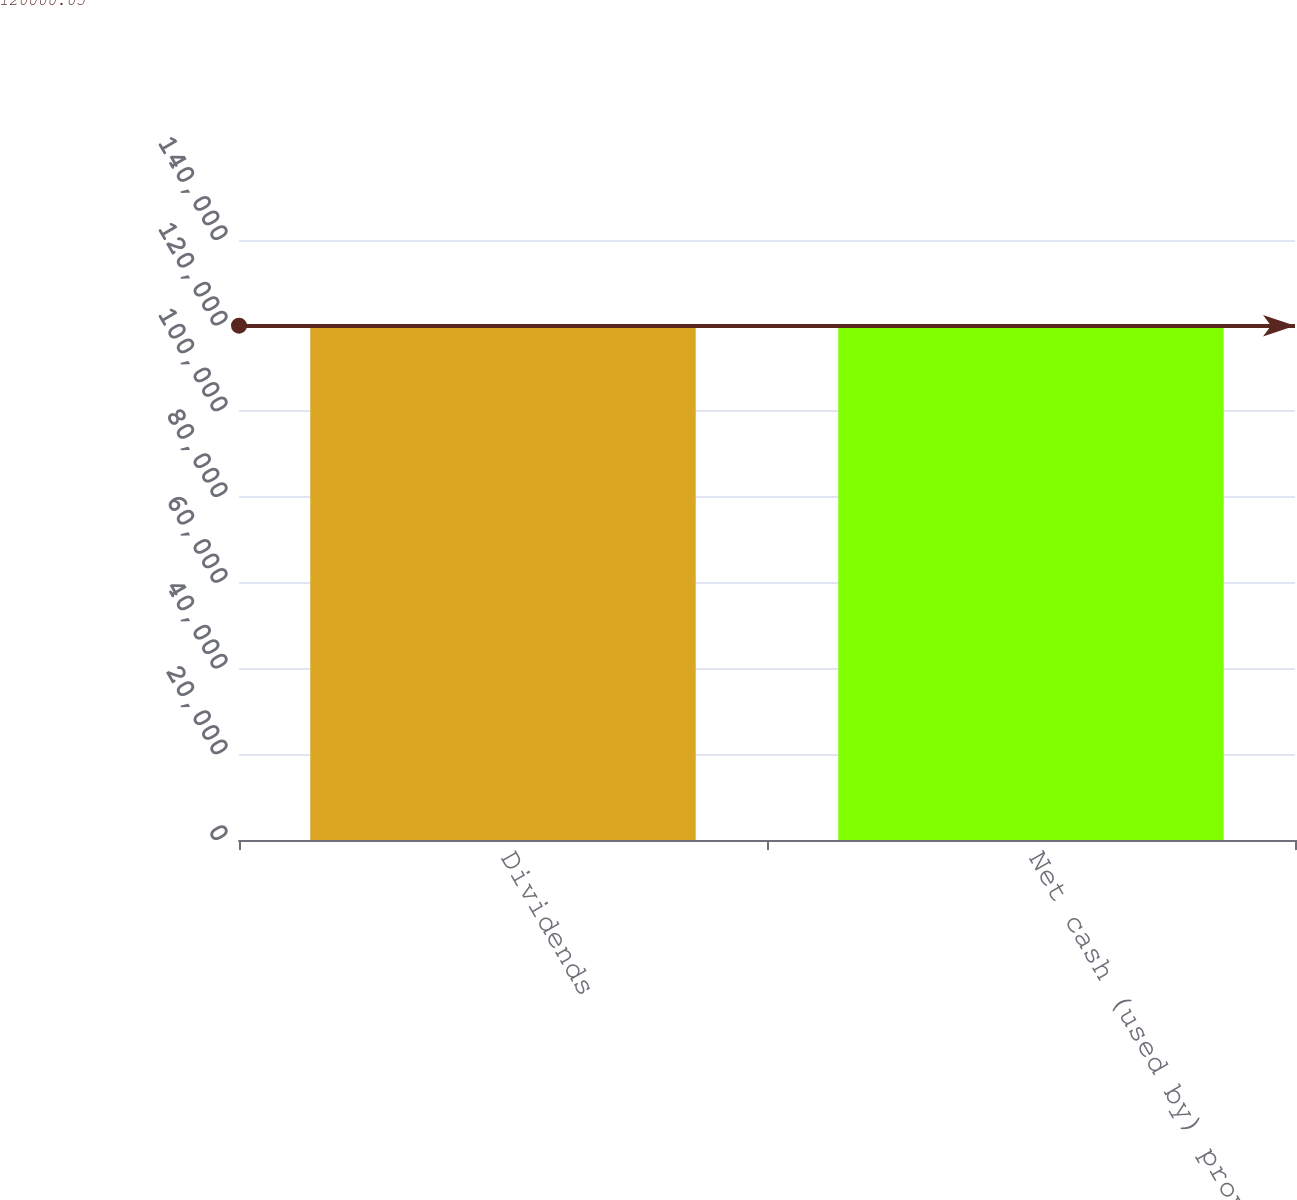Convert chart to OTSL. <chart><loc_0><loc_0><loc_500><loc_500><bar_chart><fcel>Dividends<fcel>Net cash (used by) provided by<nl><fcel>120000<fcel>120000<nl></chart> 